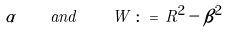<formula> <loc_0><loc_0><loc_500><loc_500>\alpha \quad { a n d } \quad W \, \colon = \, R ^ { 2 } - \beta ^ { 2 }</formula> 